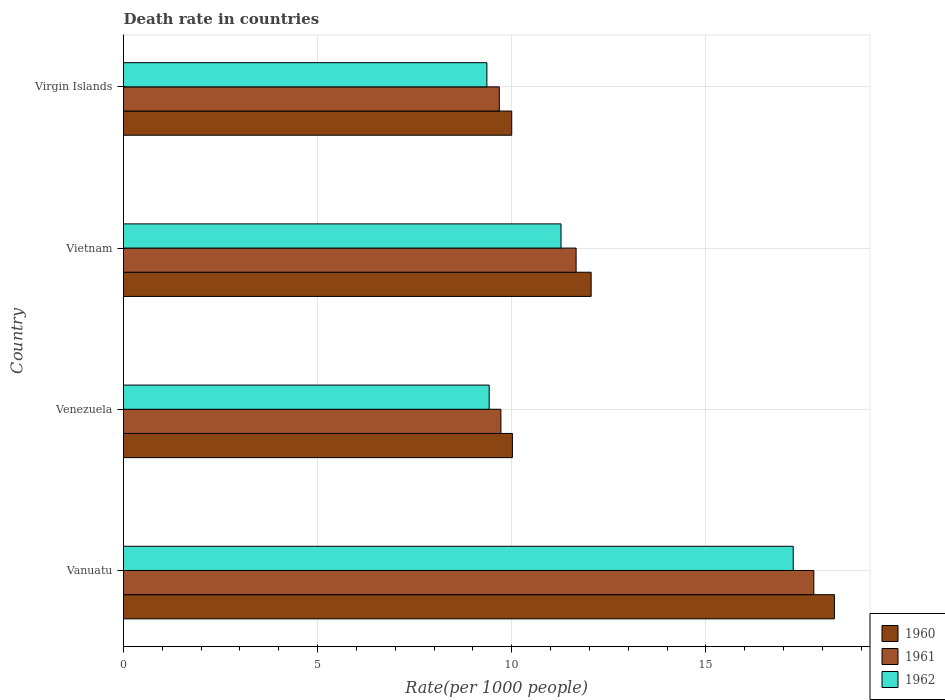How many groups of bars are there?
Offer a terse response. 4. How many bars are there on the 1st tick from the bottom?
Your response must be concise. 3. What is the label of the 1st group of bars from the top?
Your answer should be compact. Virgin Islands. In how many cases, is the number of bars for a given country not equal to the number of legend labels?
Provide a succinct answer. 0. What is the death rate in 1962 in Vanuatu?
Keep it short and to the point. 17.25. Across all countries, what is the maximum death rate in 1961?
Give a very brief answer. 17.78. Across all countries, what is the minimum death rate in 1962?
Keep it short and to the point. 9.36. In which country was the death rate in 1960 maximum?
Provide a short and direct response. Vanuatu. In which country was the death rate in 1961 minimum?
Your answer should be very brief. Virgin Islands. What is the total death rate in 1960 in the graph?
Offer a very short reply. 50.37. What is the difference between the death rate in 1961 in Vanuatu and that in Venezuela?
Keep it short and to the point. 8.06. What is the difference between the death rate in 1961 in Virgin Islands and the death rate in 1962 in Vanuatu?
Ensure brevity in your answer.  -7.57. What is the average death rate in 1961 per country?
Offer a very short reply. 12.21. What is the difference between the death rate in 1960 and death rate in 1961 in Venezuela?
Make the answer very short. 0.3. What is the ratio of the death rate in 1960 in Vanuatu to that in Vietnam?
Offer a terse response. 1.52. What is the difference between the highest and the second highest death rate in 1961?
Keep it short and to the point. 6.12. What is the difference between the highest and the lowest death rate in 1960?
Provide a short and direct response. 8.31. Is the sum of the death rate in 1961 in Vanuatu and Vietnam greater than the maximum death rate in 1960 across all countries?
Your answer should be very brief. Yes. Is it the case that in every country, the sum of the death rate in 1960 and death rate in 1961 is greater than the death rate in 1962?
Offer a terse response. Yes. How many bars are there?
Provide a succinct answer. 12. How many countries are there in the graph?
Provide a short and direct response. 4. Does the graph contain any zero values?
Your response must be concise. No. Does the graph contain grids?
Make the answer very short. Yes. How many legend labels are there?
Your answer should be very brief. 3. What is the title of the graph?
Your answer should be compact. Death rate in countries. Does "1977" appear as one of the legend labels in the graph?
Your answer should be very brief. No. What is the label or title of the X-axis?
Offer a very short reply. Rate(per 1000 people). What is the label or title of the Y-axis?
Offer a terse response. Country. What is the Rate(per 1000 people) of 1960 in Vanuatu?
Provide a succinct answer. 18.31. What is the Rate(per 1000 people) of 1961 in Vanuatu?
Your response must be concise. 17.78. What is the Rate(per 1000 people) of 1962 in Vanuatu?
Your answer should be compact. 17.25. What is the Rate(per 1000 people) of 1960 in Venezuela?
Give a very brief answer. 10.02. What is the Rate(per 1000 people) in 1961 in Venezuela?
Ensure brevity in your answer.  9.72. What is the Rate(per 1000 people) of 1962 in Venezuela?
Keep it short and to the point. 9.42. What is the Rate(per 1000 people) of 1960 in Vietnam?
Keep it short and to the point. 12.04. What is the Rate(per 1000 people) of 1961 in Vietnam?
Offer a very short reply. 11.66. What is the Rate(per 1000 people) in 1962 in Vietnam?
Ensure brevity in your answer.  11.27. What is the Rate(per 1000 people) of 1960 in Virgin Islands?
Provide a short and direct response. 10. What is the Rate(per 1000 people) in 1961 in Virgin Islands?
Give a very brief answer. 9.68. What is the Rate(per 1000 people) of 1962 in Virgin Islands?
Offer a terse response. 9.36. Across all countries, what is the maximum Rate(per 1000 people) in 1960?
Your answer should be compact. 18.31. Across all countries, what is the maximum Rate(per 1000 people) of 1961?
Keep it short and to the point. 17.78. Across all countries, what is the maximum Rate(per 1000 people) in 1962?
Give a very brief answer. 17.25. Across all countries, what is the minimum Rate(per 1000 people) of 1960?
Make the answer very short. 10. Across all countries, what is the minimum Rate(per 1000 people) of 1961?
Make the answer very short. 9.68. Across all countries, what is the minimum Rate(per 1000 people) in 1962?
Offer a terse response. 9.36. What is the total Rate(per 1000 people) of 1960 in the graph?
Offer a terse response. 50.37. What is the total Rate(per 1000 people) of 1961 in the graph?
Offer a very short reply. 48.84. What is the total Rate(per 1000 people) of 1962 in the graph?
Keep it short and to the point. 47.3. What is the difference between the Rate(per 1000 people) in 1960 in Vanuatu and that in Venezuela?
Keep it short and to the point. 8.29. What is the difference between the Rate(per 1000 people) of 1961 in Vanuatu and that in Venezuela?
Ensure brevity in your answer.  8.06. What is the difference between the Rate(per 1000 people) in 1962 in Vanuatu and that in Venezuela?
Offer a terse response. 7.83. What is the difference between the Rate(per 1000 people) of 1960 in Vanuatu and that in Vietnam?
Offer a terse response. 6.27. What is the difference between the Rate(per 1000 people) in 1961 in Vanuatu and that in Vietnam?
Your answer should be very brief. 6.12. What is the difference between the Rate(per 1000 people) in 1962 in Vanuatu and that in Vietnam?
Offer a terse response. 5.98. What is the difference between the Rate(per 1000 people) in 1960 in Vanuatu and that in Virgin Islands?
Provide a short and direct response. 8.31. What is the difference between the Rate(per 1000 people) in 1961 in Vanuatu and that in Virgin Islands?
Offer a terse response. 8.1. What is the difference between the Rate(per 1000 people) of 1962 in Vanuatu and that in Virgin Islands?
Keep it short and to the point. 7.89. What is the difference between the Rate(per 1000 people) in 1960 in Venezuela and that in Vietnam?
Provide a short and direct response. -2.03. What is the difference between the Rate(per 1000 people) of 1961 in Venezuela and that in Vietnam?
Your answer should be compact. -1.94. What is the difference between the Rate(per 1000 people) of 1962 in Venezuela and that in Vietnam?
Your response must be concise. -1.85. What is the difference between the Rate(per 1000 people) of 1960 in Venezuela and that in Virgin Islands?
Your response must be concise. 0.02. What is the difference between the Rate(per 1000 people) of 1961 in Venezuela and that in Virgin Islands?
Make the answer very short. 0.04. What is the difference between the Rate(per 1000 people) of 1962 in Venezuela and that in Virgin Islands?
Keep it short and to the point. 0.06. What is the difference between the Rate(per 1000 people) in 1960 in Vietnam and that in Virgin Islands?
Ensure brevity in your answer.  2.04. What is the difference between the Rate(per 1000 people) of 1961 in Vietnam and that in Virgin Islands?
Your response must be concise. 1.98. What is the difference between the Rate(per 1000 people) of 1962 in Vietnam and that in Virgin Islands?
Give a very brief answer. 1.91. What is the difference between the Rate(per 1000 people) in 1960 in Vanuatu and the Rate(per 1000 people) in 1961 in Venezuela?
Offer a terse response. 8.59. What is the difference between the Rate(per 1000 people) of 1960 in Vanuatu and the Rate(per 1000 people) of 1962 in Venezuela?
Offer a very short reply. 8.89. What is the difference between the Rate(per 1000 people) of 1961 in Vanuatu and the Rate(per 1000 people) of 1962 in Venezuela?
Provide a succinct answer. 8.36. What is the difference between the Rate(per 1000 people) of 1960 in Vanuatu and the Rate(per 1000 people) of 1961 in Vietnam?
Offer a terse response. 6.65. What is the difference between the Rate(per 1000 people) in 1960 in Vanuatu and the Rate(per 1000 people) in 1962 in Vietnam?
Provide a short and direct response. 7.04. What is the difference between the Rate(per 1000 people) of 1961 in Vanuatu and the Rate(per 1000 people) of 1962 in Vietnam?
Give a very brief answer. 6.51. What is the difference between the Rate(per 1000 people) in 1960 in Vanuatu and the Rate(per 1000 people) in 1961 in Virgin Islands?
Give a very brief answer. 8.63. What is the difference between the Rate(per 1000 people) of 1960 in Vanuatu and the Rate(per 1000 people) of 1962 in Virgin Islands?
Your answer should be compact. 8.95. What is the difference between the Rate(per 1000 people) of 1961 in Vanuatu and the Rate(per 1000 people) of 1962 in Virgin Islands?
Keep it short and to the point. 8.42. What is the difference between the Rate(per 1000 people) of 1960 in Venezuela and the Rate(per 1000 people) of 1961 in Vietnam?
Make the answer very short. -1.64. What is the difference between the Rate(per 1000 people) in 1960 in Venezuela and the Rate(per 1000 people) in 1962 in Vietnam?
Your answer should be compact. -1.25. What is the difference between the Rate(per 1000 people) in 1961 in Venezuela and the Rate(per 1000 people) in 1962 in Vietnam?
Your answer should be compact. -1.55. What is the difference between the Rate(per 1000 people) of 1960 in Venezuela and the Rate(per 1000 people) of 1961 in Virgin Islands?
Keep it short and to the point. 0.34. What is the difference between the Rate(per 1000 people) in 1960 in Venezuela and the Rate(per 1000 people) in 1962 in Virgin Islands?
Make the answer very short. 0.66. What is the difference between the Rate(per 1000 people) of 1961 in Venezuela and the Rate(per 1000 people) of 1962 in Virgin Islands?
Make the answer very short. 0.36. What is the difference between the Rate(per 1000 people) of 1960 in Vietnam and the Rate(per 1000 people) of 1961 in Virgin Islands?
Keep it short and to the point. 2.37. What is the difference between the Rate(per 1000 people) of 1960 in Vietnam and the Rate(per 1000 people) of 1962 in Virgin Islands?
Your answer should be very brief. 2.69. What is the difference between the Rate(per 1000 people) in 1961 in Vietnam and the Rate(per 1000 people) in 1962 in Virgin Islands?
Provide a short and direct response. 2.3. What is the average Rate(per 1000 people) of 1960 per country?
Your answer should be compact. 12.59. What is the average Rate(per 1000 people) of 1961 per country?
Your answer should be very brief. 12.21. What is the average Rate(per 1000 people) of 1962 per country?
Ensure brevity in your answer.  11.82. What is the difference between the Rate(per 1000 people) of 1960 and Rate(per 1000 people) of 1961 in Vanuatu?
Your answer should be very brief. 0.53. What is the difference between the Rate(per 1000 people) of 1960 and Rate(per 1000 people) of 1962 in Vanuatu?
Offer a very short reply. 1.06. What is the difference between the Rate(per 1000 people) of 1961 and Rate(per 1000 people) of 1962 in Vanuatu?
Give a very brief answer. 0.53. What is the difference between the Rate(per 1000 people) in 1960 and Rate(per 1000 people) in 1961 in Venezuela?
Keep it short and to the point. 0.3. What is the difference between the Rate(per 1000 people) of 1960 and Rate(per 1000 people) of 1962 in Venezuela?
Offer a very short reply. 0.6. What is the difference between the Rate(per 1000 people) in 1961 and Rate(per 1000 people) in 1962 in Venezuela?
Offer a terse response. 0.3. What is the difference between the Rate(per 1000 people) in 1960 and Rate(per 1000 people) in 1961 in Vietnam?
Offer a very short reply. 0.39. What is the difference between the Rate(per 1000 people) in 1960 and Rate(per 1000 people) in 1962 in Vietnam?
Your answer should be compact. 0.78. What is the difference between the Rate(per 1000 people) of 1961 and Rate(per 1000 people) of 1962 in Vietnam?
Offer a terse response. 0.39. What is the difference between the Rate(per 1000 people) of 1960 and Rate(per 1000 people) of 1961 in Virgin Islands?
Ensure brevity in your answer.  0.32. What is the difference between the Rate(per 1000 people) of 1960 and Rate(per 1000 people) of 1962 in Virgin Islands?
Offer a terse response. 0.64. What is the difference between the Rate(per 1000 people) of 1961 and Rate(per 1000 people) of 1962 in Virgin Islands?
Ensure brevity in your answer.  0.32. What is the ratio of the Rate(per 1000 people) in 1960 in Vanuatu to that in Venezuela?
Your answer should be very brief. 1.83. What is the ratio of the Rate(per 1000 people) in 1961 in Vanuatu to that in Venezuela?
Ensure brevity in your answer.  1.83. What is the ratio of the Rate(per 1000 people) in 1962 in Vanuatu to that in Venezuela?
Keep it short and to the point. 1.83. What is the ratio of the Rate(per 1000 people) of 1960 in Vanuatu to that in Vietnam?
Provide a short and direct response. 1.52. What is the ratio of the Rate(per 1000 people) in 1961 in Vanuatu to that in Vietnam?
Your response must be concise. 1.53. What is the ratio of the Rate(per 1000 people) of 1962 in Vanuatu to that in Vietnam?
Keep it short and to the point. 1.53. What is the ratio of the Rate(per 1000 people) of 1960 in Vanuatu to that in Virgin Islands?
Your answer should be compact. 1.83. What is the ratio of the Rate(per 1000 people) in 1961 in Vanuatu to that in Virgin Islands?
Your answer should be very brief. 1.84. What is the ratio of the Rate(per 1000 people) in 1962 in Vanuatu to that in Virgin Islands?
Offer a terse response. 1.84. What is the ratio of the Rate(per 1000 people) of 1960 in Venezuela to that in Vietnam?
Your answer should be compact. 0.83. What is the ratio of the Rate(per 1000 people) of 1961 in Venezuela to that in Vietnam?
Offer a very short reply. 0.83. What is the ratio of the Rate(per 1000 people) in 1962 in Venezuela to that in Vietnam?
Your answer should be very brief. 0.84. What is the ratio of the Rate(per 1000 people) in 1960 in Venezuela to that in Virgin Islands?
Provide a short and direct response. 1. What is the ratio of the Rate(per 1000 people) of 1961 in Venezuela to that in Virgin Islands?
Ensure brevity in your answer.  1. What is the ratio of the Rate(per 1000 people) in 1960 in Vietnam to that in Virgin Islands?
Give a very brief answer. 1.2. What is the ratio of the Rate(per 1000 people) in 1961 in Vietnam to that in Virgin Islands?
Offer a terse response. 1.2. What is the ratio of the Rate(per 1000 people) of 1962 in Vietnam to that in Virgin Islands?
Provide a succinct answer. 1.2. What is the difference between the highest and the second highest Rate(per 1000 people) of 1960?
Provide a succinct answer. 6.27. What is the difference between the highest and the second highest Rate(per 1000 people) in 1961?
Provide a short and direct response. 6.12. What is the difference between the highest and the second highest Rate(per 1000 people) in 1962?
Provide a succinct answer. 5.98. What is the difference between the highest and the lowest Rate(per 1000 people) in 1960?
Make the answer very short. 8.31. What is the difference between the highest and the lowest Rate(per 1000 people) in 1961?
Give a very brief answer. 8.1. What is the difference between the highest and the lowest Rate(per 1000 people) in 1962?
Your answer should be compact. 7.89. 